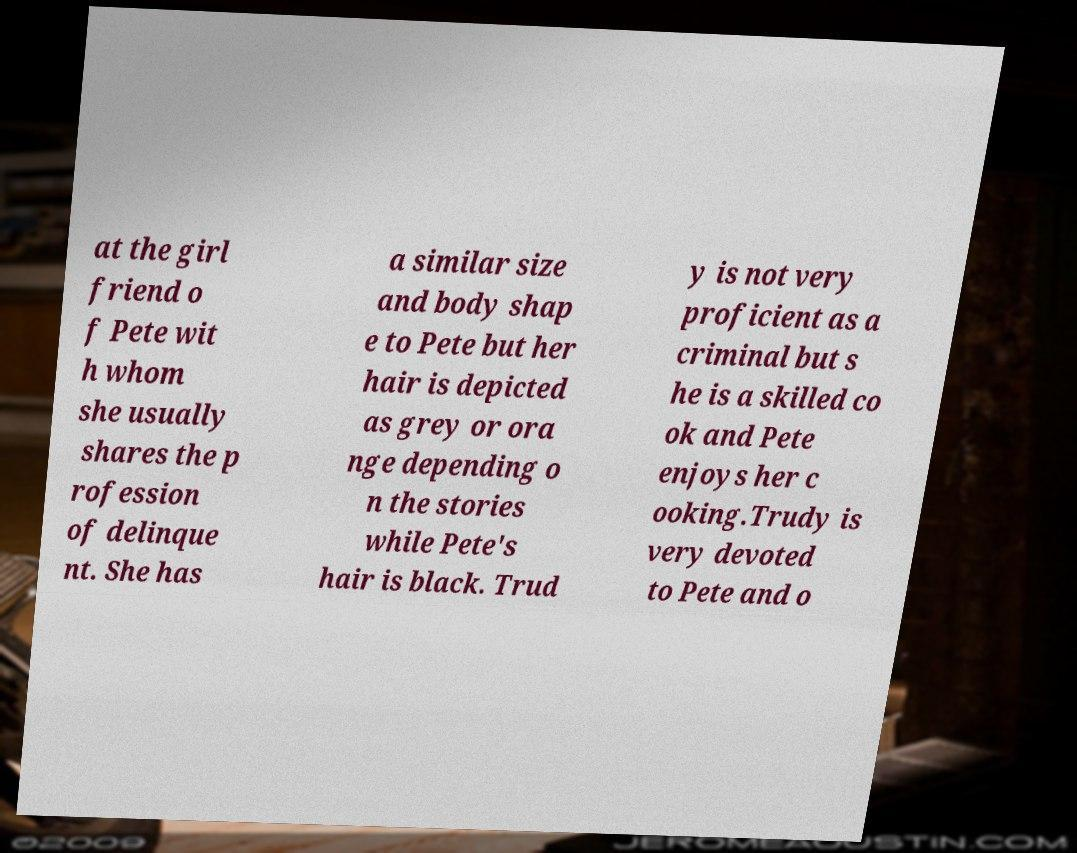Can you accurately transcribe the text from the provided image for me? at the girl friend o f Pete wit h whom she usually shares the p rofession of delinque nt. She has a similar size and body shap e to Pete but her hair is depicted as grey or ora nge depending o n the stories while Pete's hair is black. Trud y is not very proficient as a criminal but s he is a skilled co ok and Pete enjoys her c ooking.Trudy is very devoted to Pete and o 